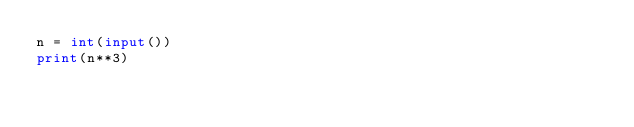Convert code to text. <code><loc_0><loc_0><loc_500><loc_500><_Python_>n = int(input())
print(n**3)</code> 